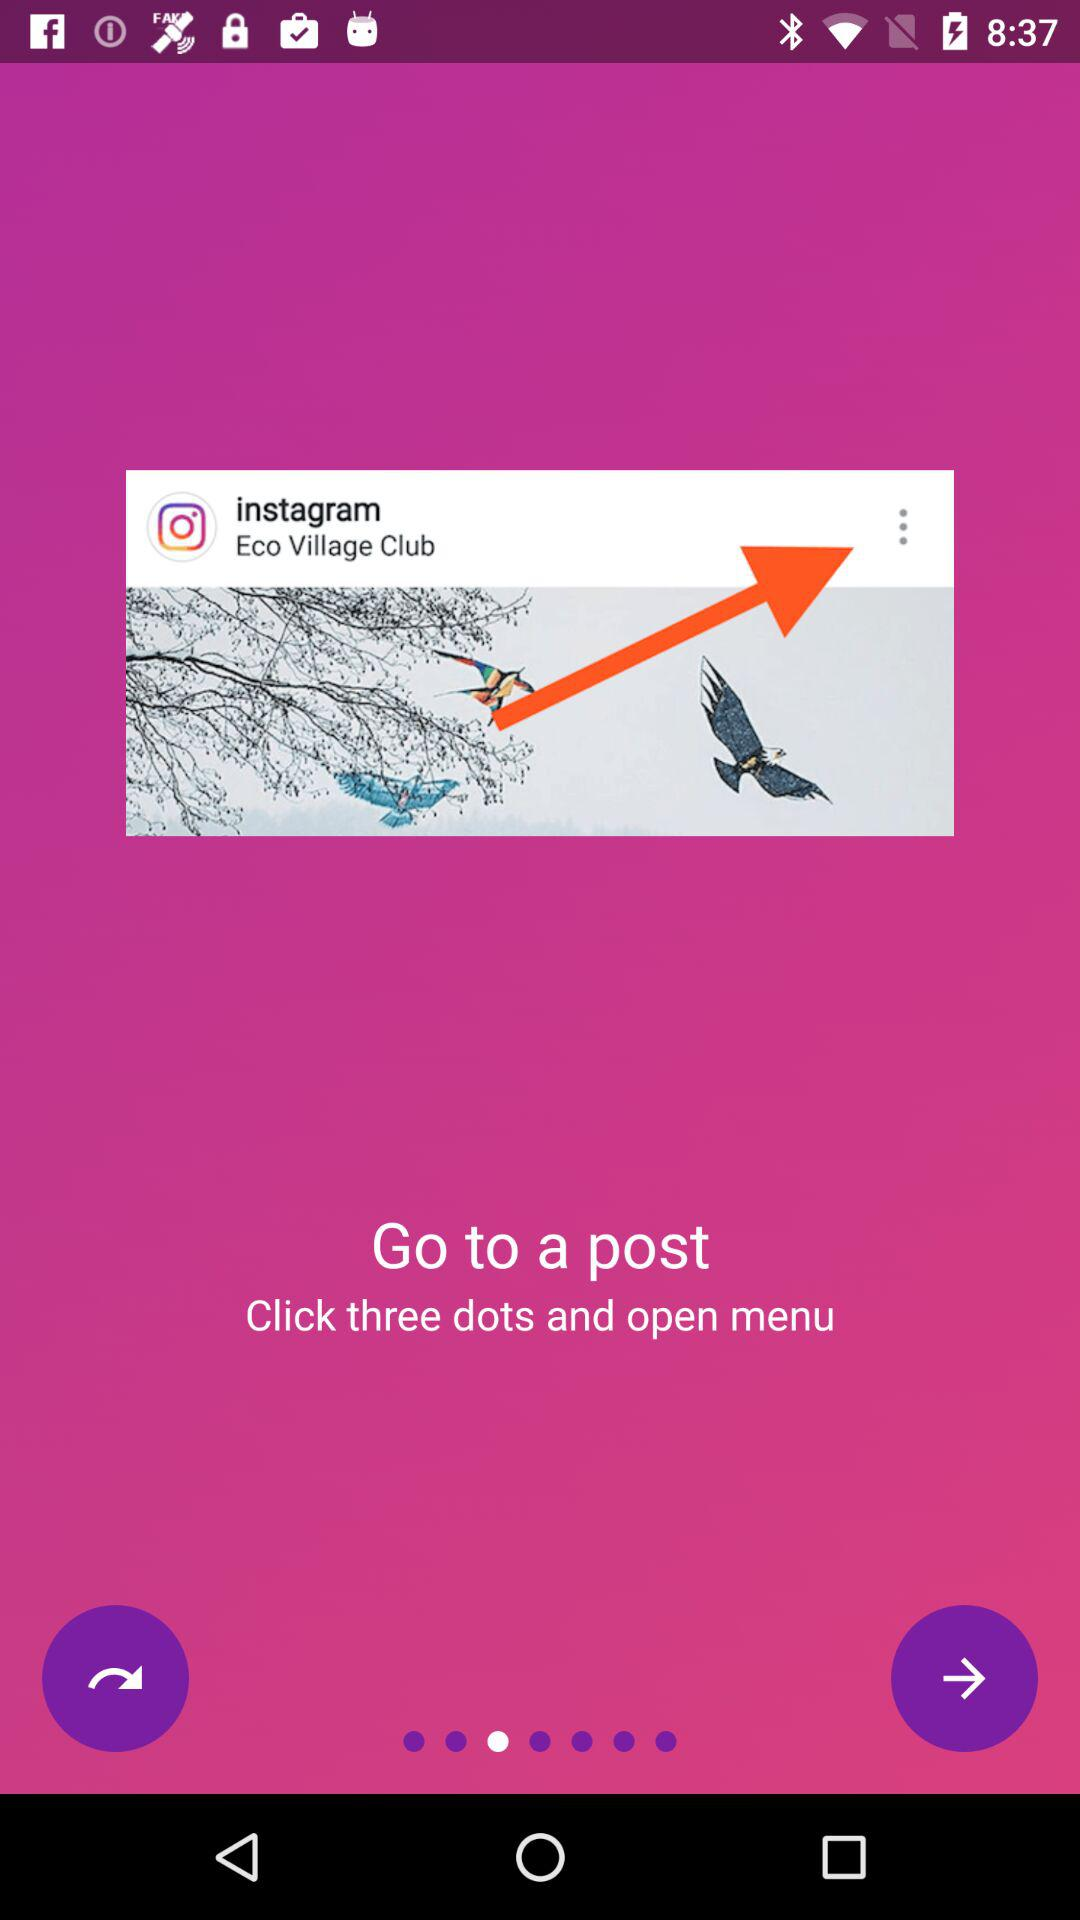How many members does the "instagram Eco Village Club" have?
When the provided information is insufficient, respond with <no answer>. <no answer> 